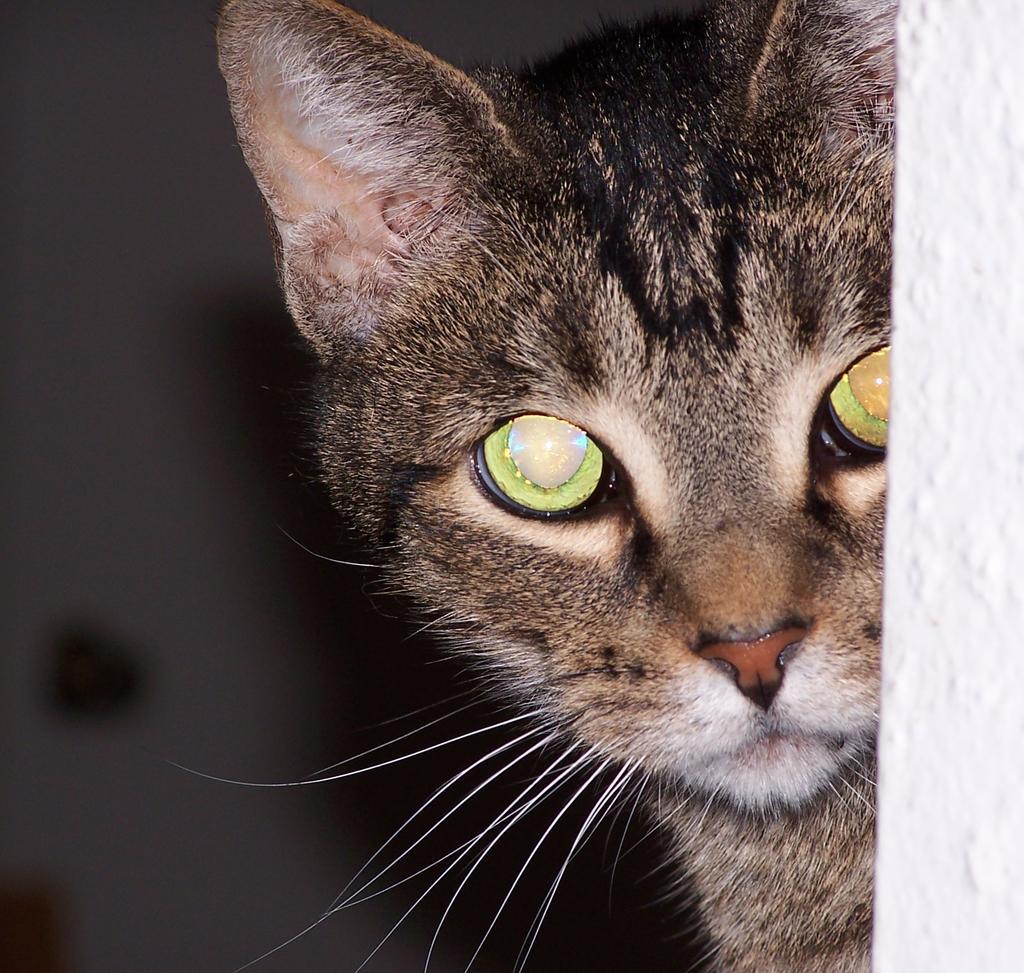Could you give a brief overview of what you see in this image? In this image, I can see a cat. On the right side of the image, it looks like a wall. There is a blurred background. 